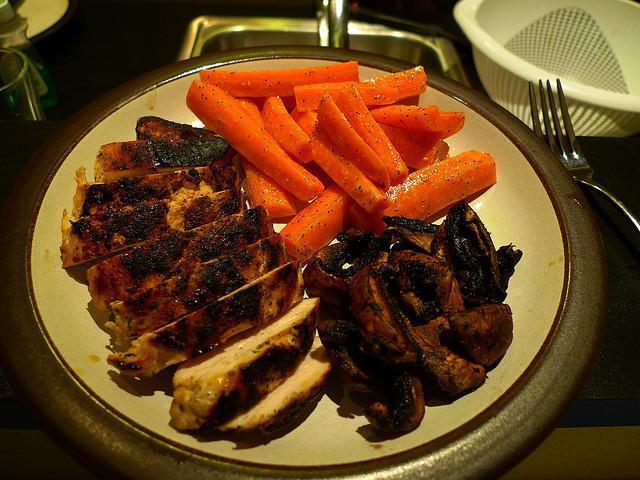How many carrots can be seen?
Give a very brief answer. 7. How many sheep are there?
Give a very brief answer. 0. 